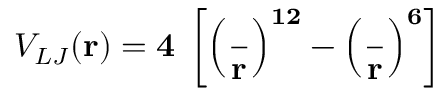Convert formula to latex. <formula><loc_0><loc_0><loc_500><loc_500>V _ { L J } ( r ) = 4 \epsilon \left [ \left ( \frac { \sigma } { r } \right ) ^ { 1 2 } - \left ( \frac { \sigma } { r } \right ) ^ { 6 } \right ]</formula> 